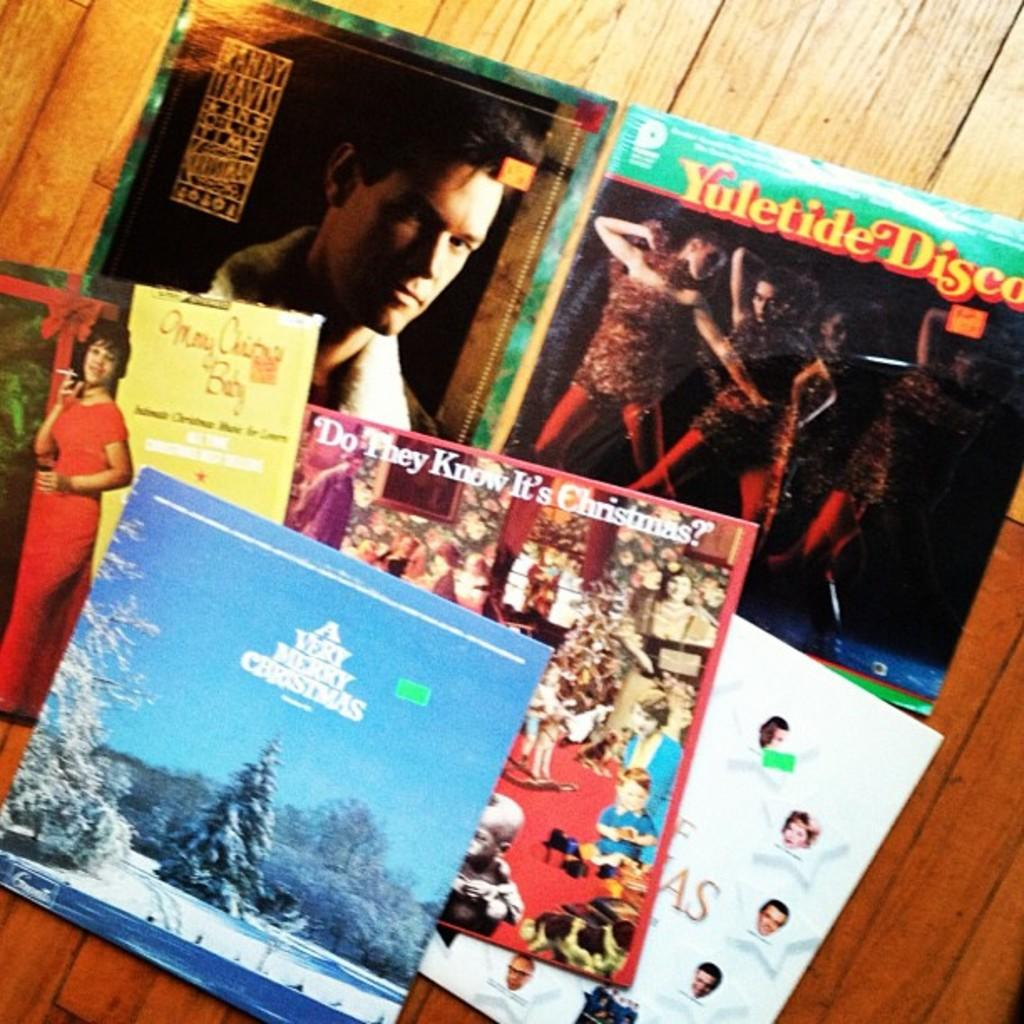<image>
Give a short and clear explanation of the subsequent image. A record titled Yuletide Disco in a pile of records. 